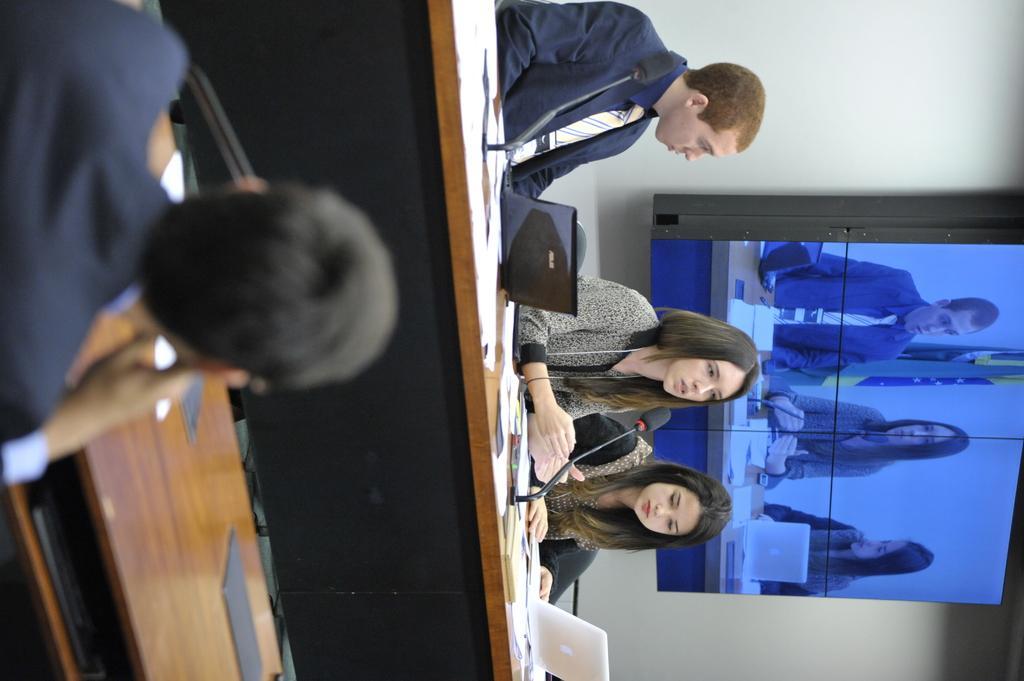Please provide a concise description of this image. Here in this picture we can see three people sitting on chairs with table in front of them having laptops and microphones and files on it over there and the woman in the middle is speaking something in the microphone present over there and behind them we can see monitor screen, in which they are focused and in front of them also we can see other people sitting with tables in front of them over there. 